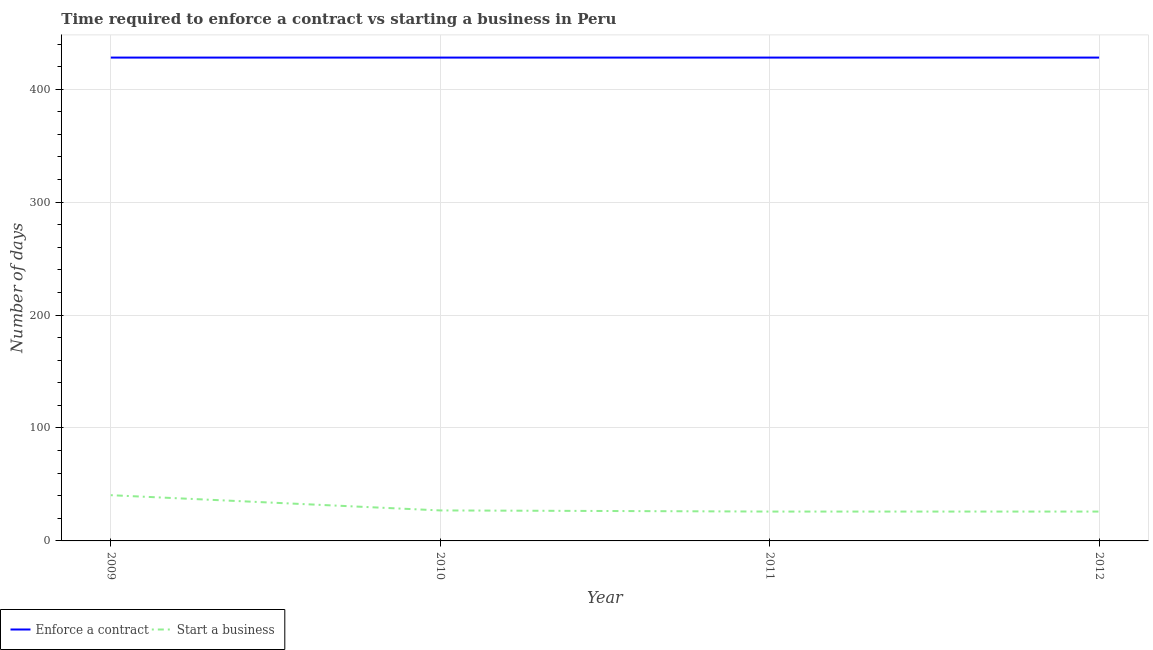How many different coloured lines are there?
Your answer should be compact. 2. Does the line corresponding to number of days to start a business intersect with the line corresponding to number of days to enforece a contract?
Your answer should be compact. No. Across all years, what is the maximum number of days to start a business?
Give a very brief answer. 40.5. Across all years, what is the minimum number of days to enforece a contract?
Offer a terse response. 428. What is the total number of days to start a business in the graph?
Provide a succinct answer. 119.5. What is the difference between the number of days to start a business in 2009 and that in 2012?
Offer a terse response. 14.5. What is the difference between the number of days to start a business in 2009 and the number of days to enforece a contract in 2012?
Your response must be concise. -387.5. What is the average number of days to enforece a contract per year?
Provide a short and direct response. 428. In the year 2010, what is the difference between the number of days to start a business and number of days to enforece a contract?
Your answer should be very brief. -401. In how many years, is the number of days to enforece a contract greater than 140 days?
Provide a succinct answer. 4. What is the ratio of the number of days to start a business in 2010 to that in 2012?
Provide a succinct answer. 1.04. Is the number of days to start a business in 2009 less than that in 2010?
Keep it short and to the point. No. In how many years, is the number of days to enforece a contract greater than the average number of days to enforece a contract taken over all years?
Ensure brevity in your answer.  0. Is the number of days to start a business strictly greater than the number of days to enforece a contract over the years?
Make the answer very short. No. Is the number of days to start a business strictly less than the number of days to enforece a contract over the years?
Your response must be concise. Yes. How many lines are there?
Your answer should be compact. 2. How many years are there in the graph?
Provide a short and direct response. 4. Does the graph contain any zero values?
Keep it short and to the point. No. Does the graph contain grids?
Give a very brief answer. Yes. Where does the legend appear in the graph?
Offer a very short reply. Bottom left. How many legend labels are there?
Make the answer very short. 2. How are the legend labels stacked?
Your answer should be compact. Horizontal. What is the title of the graph?
Provide a succinct answer. Time required to enforce a contract vs starting a business in Peru. Does "Investment" appear as one of the legend labels in the graph?
Keep it short and to the point. No. What is the label or title of the Y-axis?
Keep it short and to the point. Number of days. What is the Number of days of Enforce a contract in 2009?
Provide a succinct answer. 428. What is the Number of days of Start a business in 2009?
Keep it short and to the point. 40.5. What is the Number of days in Enforce a contract in 2010?
Provide a short and direct response. 428. What is the Number of days of Start a business in 2010?
Your answer should be compact. 27. What is the Number of days in Enforce a contract in 2011?
Offer a very short reply. 428. What is the Number of days in Start a business in 2011?
Your response must be concise. 26. What is the Number of days of Enforce a contract in 2012?
Your answer should be very brief. 428. Across all years, what is the maximum Number of days in Enforce a contract?
Give a very brief answer. 428. Across all years, what is the maximum Number of days in Start a business?
Keep it short and to the point. 40.5. Across all years, what is the minimum Number of days in Enforce a contract?
Make the answer very short. 428. Across all years, what is the minimum Number of days of Start a business?
Your answer should be very brief. 26. What is the total Number of days of Enforce a contract in the graph?
Your answer should be very brief. 1712. What is the total Number of days in Start a business in the graph?
Make the answer very short. 119.5. What is the difference between the Number of days in Enforce a contract in 2009 and that in 2010?
Your response must be concise. 0. What is the difference between the Number of days of Start a business in 2009 and that in 2010?
Ensure brevity in your answer.  13.5. What is the difference between the Number of days of Enforce a contract in 2009 and that in 2011?
Ensure brevity in your answer.  0. What is the difference between the Number of days of Start a business in 2009 and that in 2012?
Your response must be concise. 14.5. What is the difference between the Number of days in Enforce a contract in 2010 and that in 2011?
Offer a very short reply. 0. What is the difference between the Number of days of Start a business in 2010 and that in 2011?
Make the answer very short. 1. What is the difference between the Number of days of Start a business in 2011 and that in 2012?
Give a very brief answer. 0. What is the difference between the Number of days in Enforce a contract in 2009 and the Number of days in Start a business in 2010?
Give a very brief answer. 401. What is the difference between the Number of days of Enforce a contract in 2009 and the Number of days of Start a business in 2011?
Ensure brevity in your answer.  402. What is the difference between the Number of days of Enforce a contract in 2009 and the Number of days of Start a business in 2012?
Give a very brief answer. 402. What is the difference between the Number of days of Enforce a contract in 2010 and the Number of days of Start a business in 2011?
Keep it short and to the point. 402. What is the difference between the Number of days of Enforce a contract in 2010 and the Number of days of Start a business in 2012?
Provide a succinct answer. 402. What is the difference between the Number of days in Enforce a contract in 2011 and the Number of days in Start a business in 2012?
Your response must be concise. 402. What is the average Number of days of Enforce a contract per year?
Your response must be concise. 428. What is the average Number of days of Start a business per year?
Provide a short and direct response. 29.88. In the year 2009, what is the difference between the Number of days in Enforce a contract and Number of days in Start a business?
Ensure brevity in your answer.  387.5. In the year 2010, what is the difference between the Number of days of Enforce a contract and Number of days of Start a business?
Provide a succinct answer. 401. In the year 2011, what is the difference between the Number of days in Enforce a contract and Number of days in Start a business?
Offer a very short reply. 402. In the year 2012, what is the difference between the Number of days in Enforce a contract and Number of days in Start a business?
Provide a short and direct response. 402. What is the ratio of the Number of days of Enforce a contract in 2009 to that in 2010?
Your answer should be compact. 1. What is the ratio of the Number of days in Enforce a contract in 2009 to that in 2011?
Your answer should be compact. 1. What is the ratio of the Number of days in Start a business in 2009 to that in 2011?
Offer a terse response. 1.56. What is the ratio of the Number of days of Enforce a contract in 2009 to that in 2012?
Provide a short and direct response. 1. What is the ratio of the Number of days in Start a business in 2009 to that in 2012?
Keep it short and to the point. 1.56. What is the ratio of the Number of days of Start a business in 2010 to that in 2011?
Give a very brief answer. 1.04. What is the difference between the highest and the lowest Number of days of Start a business?
Ensure brevity in your answer.  14.5. 